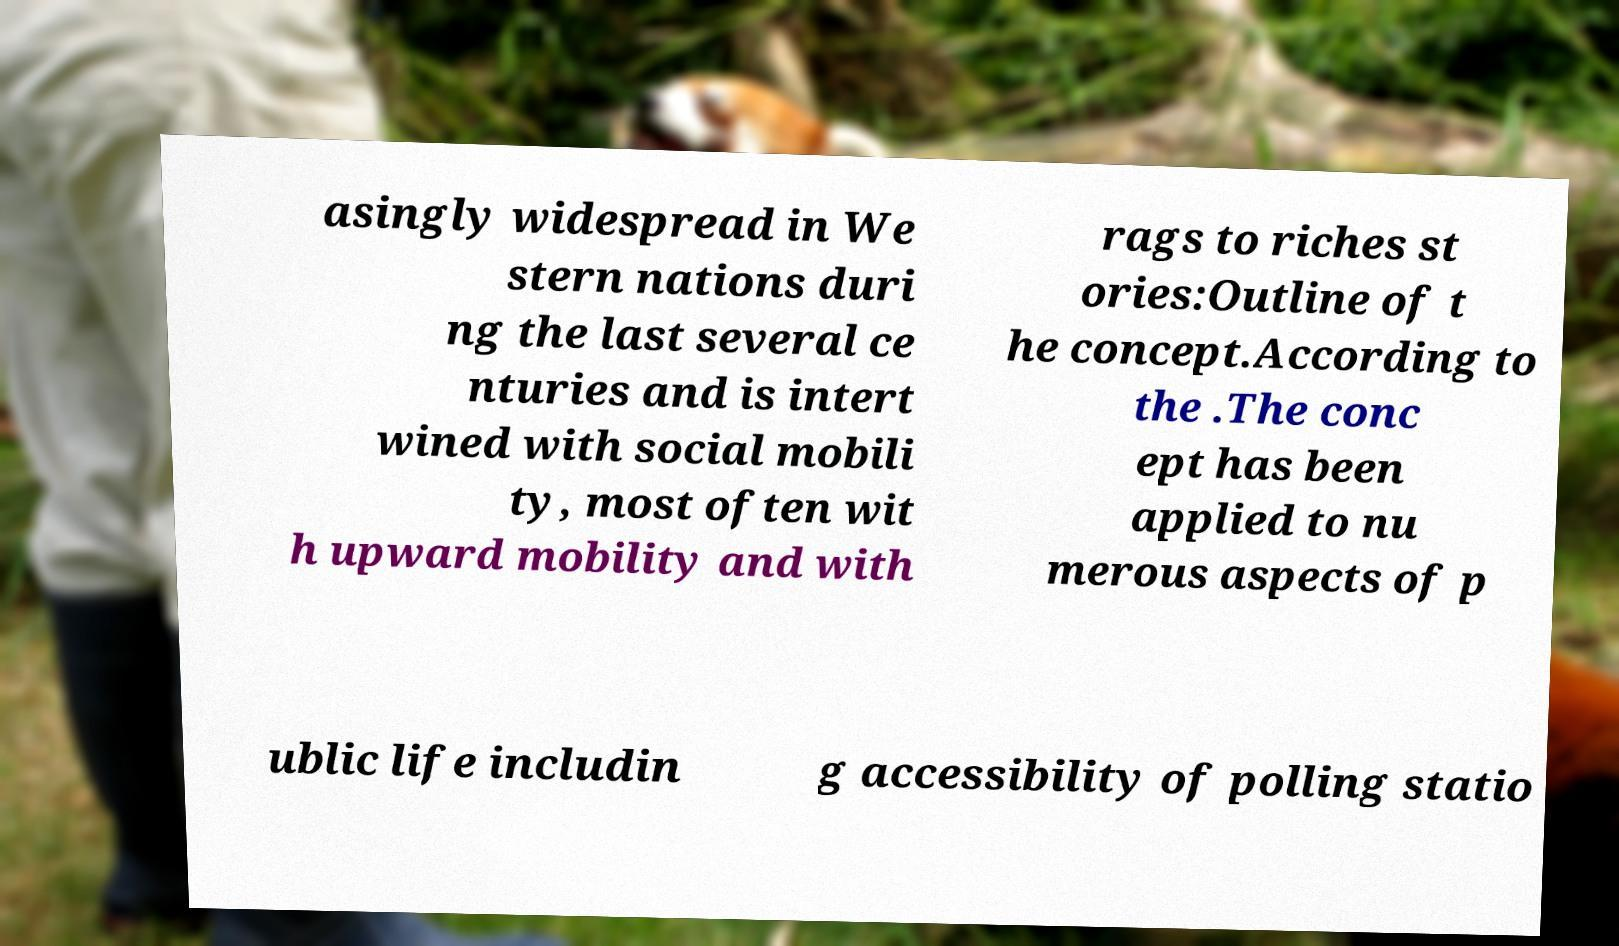Can you read and provide the text displayed in the image?This photo seems to have some interesting text. Can you extract and type it out for me? asingly widespread in We stern nations duri ng the last several ce nturies and is intert wined with social mobili ty, most often wit h upward mobility and with rags to riches st ories:Outline of t he concept.According to the .The conc ept has been applied to nu merous aspects of p ublic life includin g accessibility of polling statio 